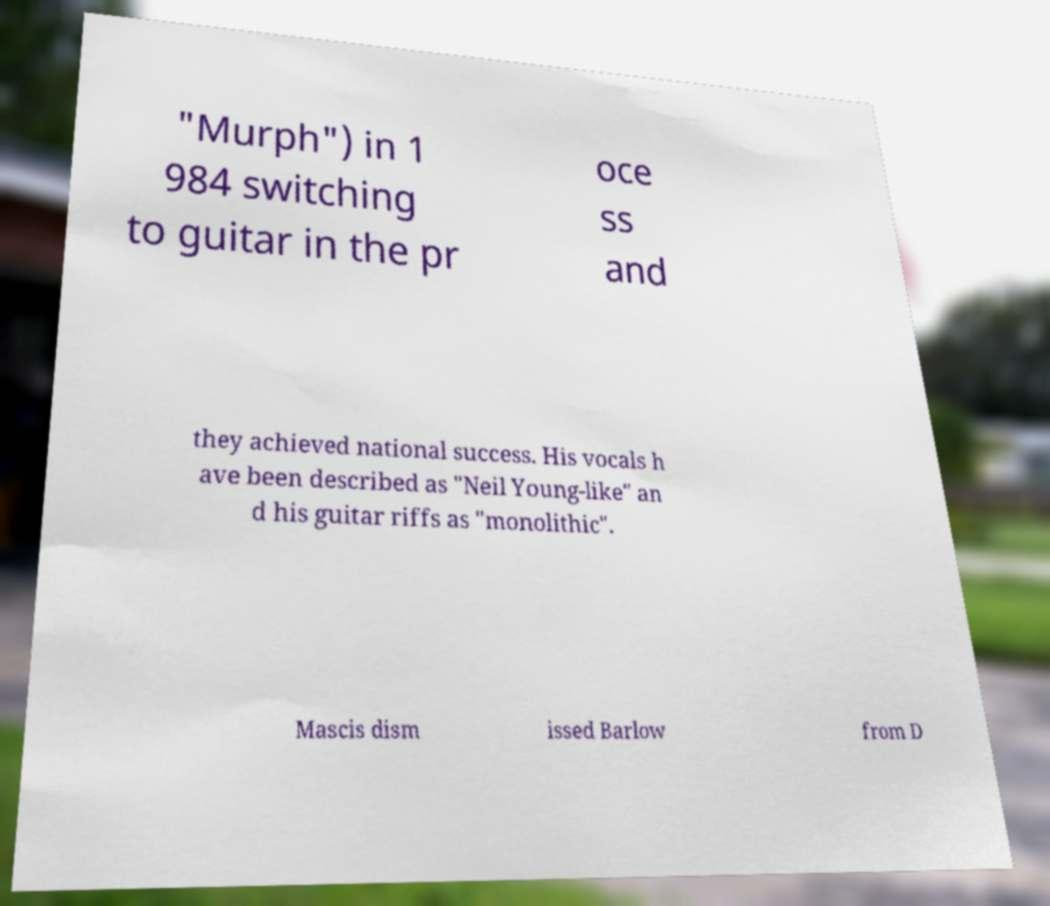Could you extract and type out the text from this image? "Murph") in 1 984 switching to guitar in the pr oce ss and they achieved national success. His vocals h ave been described as "Neil Young-like" an d his guitar riffs as "monolithic". Mascis dism issed Barlow from D 